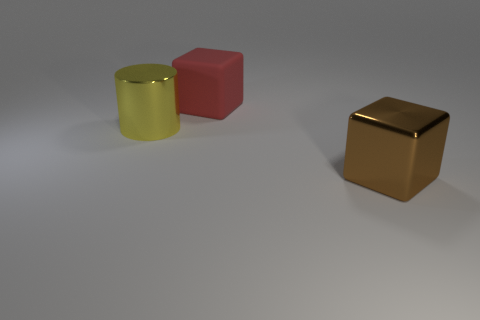Do the large shiny thing left of the brown metal cube and the object on the right side of the red object have the same shape?
Offer a very short reply. No. What is the shape of the metallic thing that is the same size as the yellow cylinder?
Offer a very short reply. Cube. The big thing that is made of the same material as the large brown block is what color?
Offer a terse response. Yellow. Is the shape of the large matte object the same as the shiny object behind the brown metal thing?
Provide a succinct answer. No. What is the material of the yellow thing that is the same size as the brown object?
Your answer should be very brief. Metal. Are there any big matte things that have the same color as the matte block?
Make the answer very short. No. The large thing that is both behind the big brown thing and right of the yellow metal cylinder has what shape?
Your response must be concise. Cube. What number of things are made of the same material as the yellow cylinder?
Ensure brevity in your answer.  1. Is the number of big brown metal cubes behind the large red block less than the number of large shiny cylinders that are right of the cylinder?
Your answer should be compact. No. The cube that is in front of the large cube left of the metallic thing on the right side of the yellow cylinder is made of what material?
Your answer should be compact. Metal. 